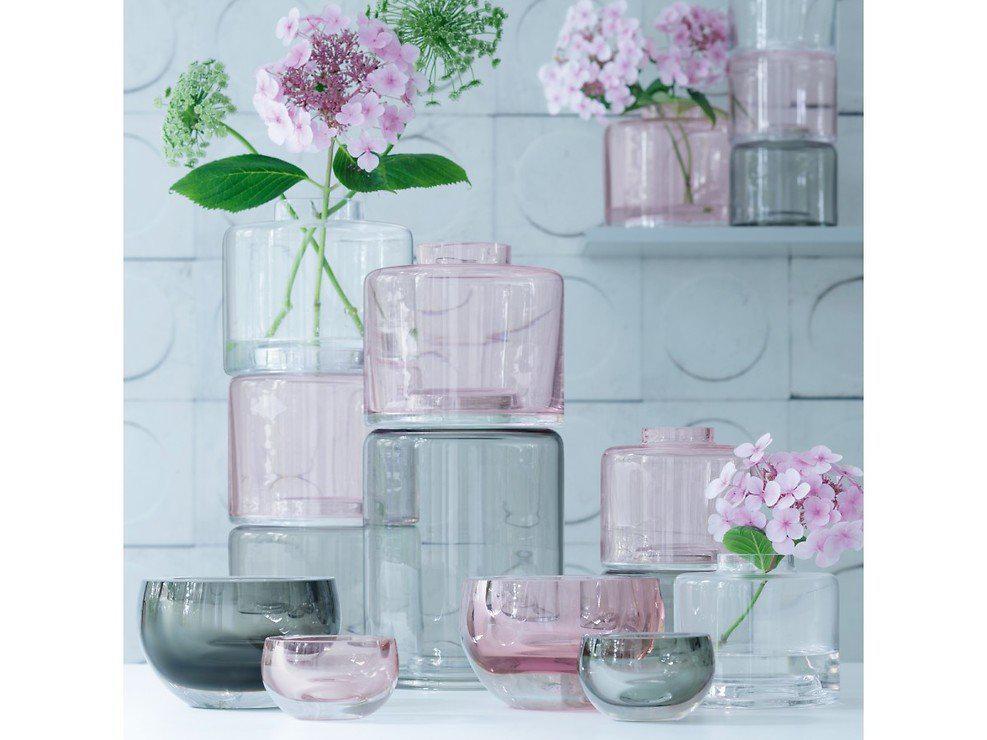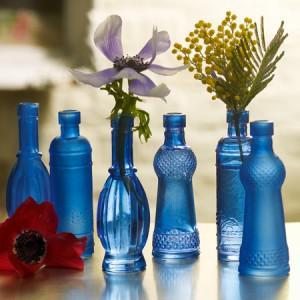The first image is the image on the left, the second image is the image on the right. Examine the images to the left and right. Is the description "An image shows vases with bold horizontal bands of color." accurate? Answer yes or no. No. 